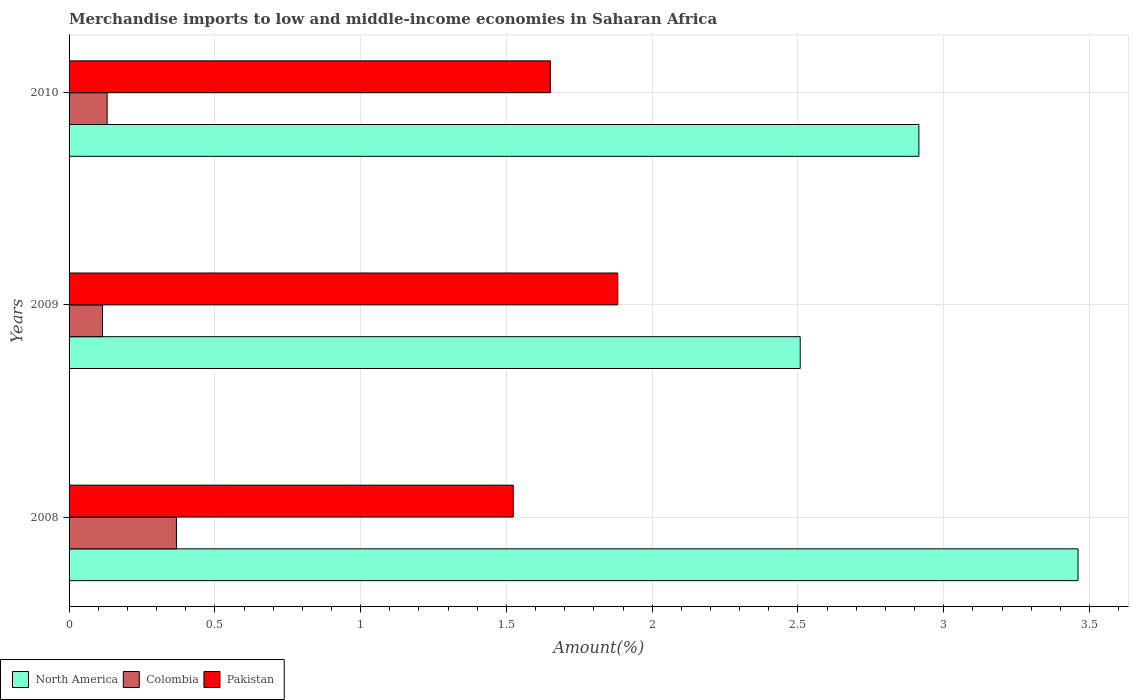How many different coloured bars are there?
Give a very brief answer. 3. How many groups of bars are there?
Ensure brevity in your answer.  3. Are the number of bars per tick equal to the number of legend labels?
Ensure brevity in your answer.  Yes. Are the number of bars on each tick of the Y-axis equal?
Provide a short and direct response. Yes. How many bars are there on the 3rd tick from the bottom?
Ensure brevity in your answer.  3. What is the label of the 1st group of bars from the top?
Ensure brevity in your answer.  2010. In how many cases, is the number of bars for a given year not equal to the number of legend labels?
Your response must be concise. 0. What is the percentage of amount earned from merchandise imports in Colombia in 2009?
Your response must be concise. 0.11. Across all years, what is the maximum percentage of amount earned from merchandise imports in North America?
Keep it short and to the point. 3.46. Across all years, what is the minimum percentage of amount earned from merchandise imports in Colombia?
Provide a short and direct response. 0.11. In which year was the percentage of amount earned from merchandise imports in Colombia maximum?
Your answer should be very brief. 2008. What is the total percentage of amount earned from merchandise imports in North America in the graph?
Give a very brief answer. 8.88. What is the difference between the percentage of amount earned from merchandise imports in Colombia in 2009 and that in 2010?
Make the answer very short. -0.02. What is the difference between the percentage of amount earned from merchandise imports in North America in 2009 and the percentage of amount earned from merchandise imports in Pakistan in 2008?
Make the answer very short. 0.98. What is the average percentage of amount earned from merchandise imports in Pakistan per year?
Keep it short and to the point. 1.69. In the year 2010, what is the difference between the percentage of amount earned from merchandise imports in North America and percentage of amount earned from merchandise imports in Pakistan?
Provide a succinct answer. 1.26. What is the ratio of the percentage of amount earned from merchandise imports in Pakistan in 2008 to that in 2009?
Provide a succinct answer. 0.81. Is the percentage of amount earned from merchandise imports in North America in 2008 less than that in 2010?
Your response must be concise. No. What is the difference between the highest and the second highest percentage of amount earned from merchandise imports in North America?
Make the answer very short. 0.55. What is the difference between the highest and the lowest percentage of amount earned from merchandise imports in North America?
Offer a very short reply. 0.95. In how many years, is the percentage of amount earned from merchandise imports in Colombia greater than the average percentage of amount earned from merchandise imports in Colombia taken over all years?
Provide a succinct answer. 1. Are all the bars in the graph horizontal?
Your answer should be compact. Yes. How many years are there in the graph?
Ensure brevity in your answer.  3. Are the values on the major ticks of X-axis written in scientific E-notation?
Provide a succinct answer. No. Does the graph contain any zero values?
Offer a very short reply. No. Does the graph contain grids?
Your answer should be very brief. Yes. Where does the legend appear in the graph?
Your answer should be very brief. Bottom left. How are the legend labels stacked?
Offer a very short reply. Horizontal. What is the title of the graph?
Provide a succinct answer. Merchandise imports to low and middle-income economies in Saharan Africa. What is the label or title of the X-axis?
Make the answer very short. Amount(%). What is the Amount(%) of North America in 2008?
Your answer should be very brief. 3.46. What is the Amount(%) of Colombia in 2008?
Provide a short and direct response. 0.37. What is the Amount(%) of Pakistan in 2008?
Provide a succinct answer. 1.52. What is the Amount(%) in North America in 2009?
Offer a terse response. 2.51. What is the Amount(%) of Colombia in 2009?
Give a very brief answer. 0.11. What is the Amount(%) of Pakistan in 2009?
Offer a terse response. 1.88. What is the Amount(%) in North America in 2010?
Ensure brevity in your answer.  2.91. What is the Amount(%) of Colombia in 2010?
Give a very brief answer. 0.13. What is the Amount(%) in Pakistan in 2010?
Your response must be concise. 1.65. Across all years, what is the maximum Amount(%) of North America?
Provide a short and direct response. 3.46. Across all years, what is the maximum Amount(%) in Colombia?
Keep it short and to the point. 0.37. Across all years, what is the maximum Amount(%) of Pakistan?
Make the answer very short. 1.88. Across all years, what is the minimum Amount(%) in North America?
Your answer should be compact. 2.51. Across all years, what is the minimum Amount(%) in Colombia?
Provide a short and direct response. 0.11. Across all years, what is the minimum Amount(%) in Pakistan?
Provide a succinct answer. 1.52. What is the total Amount(%) in North America in the graph?
Ensure brevity in your answer.  8.88. What is the total Amount(%) in Colombia in the graph?
Give a very brief answer. 0.61. What is the total Amount(%) in Pakistan in the graph?
Give a very brief answer. 5.06. What is the difference between the Amount(%) of North America in 2008 and that in 2009?
Your answer should be compact. 0.95. What is the difference between the Amount(%) in Colombia in 2008 and that in 2009?
Make the answer very short. 0.25. What is the difference between the Amount(%) in Pakistan in 2008 and that in 2009?
Keep it short and to the point. -0.36. What is the difference between the Amount(%) in North America in 2008 and that in 2010?
Offer a very short reply. 0.55. What is the difference between the Amount(%) of Colombia in 2008 and that in 2010?
Your response must be concise. 0.24. What is the difference between the Amount(%) of Pakistan in 2008 and that in 2010?
Your answer should be very brief. -0.13. What is the difference between the Amount(%) of North America in 2009 and that in 2010?
Give a very brief answer. -0.41. What is the difference between the Amount(%) of Colombia in 2009 and that in 2010?
Your response must be concise. -0.02. What is the difference between the Amount(%) of Pakistan in 2009 and that in 2010?
Ensure brevity in your answer.  0.23. What is the difference between the Amount(%) of North America in 2008 and the Amount(%) of Colombia in 2009?
Your answer should be compact. 3.35. What is the difference between the Amount(%) in North America in 2008 and the Amount(%) in Pakistan in 2009?
Your answer should be compact. 1.58. What is the difference between the Amount(%) in Colombia in 2008 and the Amount(%) in Pakistan in 2009?
Provide a succinct answer. -1.51. What is the difference between the Amount(%) of North America in 2008 and the Amount(%) of Colombia in 2010?
Your answer should be very brief. 3.33. What is the difference between the Amount(%) of North America in 2008 and the Amount(%) of Pakistan in 2010?
Give a very brief answer. 1.81. What is the difference between the Amount(%) of Colombia in 2008 and the Amount(%) of Pakistan in 2010?
Offer a terse response. -1.28. What is the difference between the Amount(%) in North America in 2009 and the Amount(%) in Colombia in 2010?
Make the answer very short. 2.38. What is the difference between the Amount(%) of North America in 2009 and the Amount(%) of Pakistan in 2010?
Give a very brief answer. 0.86. What is the difference between the Amount(%) in Colombia in 2009 and the Amount(%) in Pakistan in 2010?
Offer a very short reply. -1.54. What is the average Amount(%) of North America per year?
Your answer should be very brief. 2.96. What is the average Amount(%) of Colombia per year?
Your answer should be very brief. 0.2. What is the average Amount(%) of Pakistan per year?
Offer a very short reply. 1.69. In the year 2008, what is the difference between the Amount(%) in North America and Amount(%) in Colombia?
Your answer should be very brief. 3.09. In the year 2008, what is the difference between the Amount(%) of North America and Amount(%) of Pakistan?
Your answer should be compact. 1.94. In the year 2008, what is the difference between the Amount(%) of Colombia and Amount(%) of Pakistan?
Offer a terse response. -1.16. In the year 2009, what is the difference between the Amount(%) of North America and Amount(%) of Colombia?
Give a very brief answer. 2.39. In the year 2009, what is the difference between the Amount(%) of North America and Amount(%) of Pakistan?
Offer a terse response. 0.63. In the year 2009, what is the difference between the Amount(%) in Colombia and Amount(%) in Pakistan?
Keep it short and to the point. -1.77. In the year 2010, what is the difference between the Amount(%) in North America and Amount(%) in Colombia?
Provide a short and direct response. 2.78. In the year 2010, what is the difference between the Amount(%) in North America and Amount(%) in Pakistan?
Keep it short and to the point. 1.26. In the year 2010, what is the difference between the Amount(%) in Colombia and Amount(%) in Pakistan?
Give a very brief answer. -1.52. What is the ratio of the Amount(%) of North America in 2008 to that in 2009?
Offer a terse response. 1.38. What is the ratio of the Amount(%) in Colombia in 2008 to that in 2009?
Offer a terse response. 3.21. What is the ratio of the Amount(%) in Pakistan in 2008 to that in 2009?
Provide a succinct answer. 0.81. What is the ratio of the Amount(%) of North America in 2008 to that in 2010?
Your response must be concise. 1.19. What is the ratio of the Amount(%) in Colombia in 2008 to that in 2010?
Offer a terse response. 2.82. What is the ratio of the Amount(%) of Pakistan in 2008 to that in 2010?
Make the answer very short. 0.92. What is the ratio of the Amount(%) of North America in 2009 to that in 2010?
Make the answer very short. 0.86. What is the ratio of the Amount(%) in Colombia in 2009 to that in 2010?
Keep it short and to the point. 0.88. What is the ratio of the Amount(%) in Pakistan in 2009 to that in 2010?
Ensure brevity in your answer.  1.14. What is the difference between the highest and the second highest Amount(%) in North America?
Your answer should be very brief. 0.55. What is the difference between the highest and the second highest Amount(%) of Colombia?
Offer a terse response. 0.24. What is the difference between the highest and the second highest Amount(%) of Pakistan?
Offer a very short reply. 0.23. What is the difference between the highest and the lowest Amount(%) in North America?
Make the answer very short. 0.95. What is the difference between the highest and the lowest Amount(%) in Colombia?
Your response must be concise. 0.25. What is the difference between the highest and the lowest Amount(%) of Pakistan?
Give a very brief answer. 0.36. 